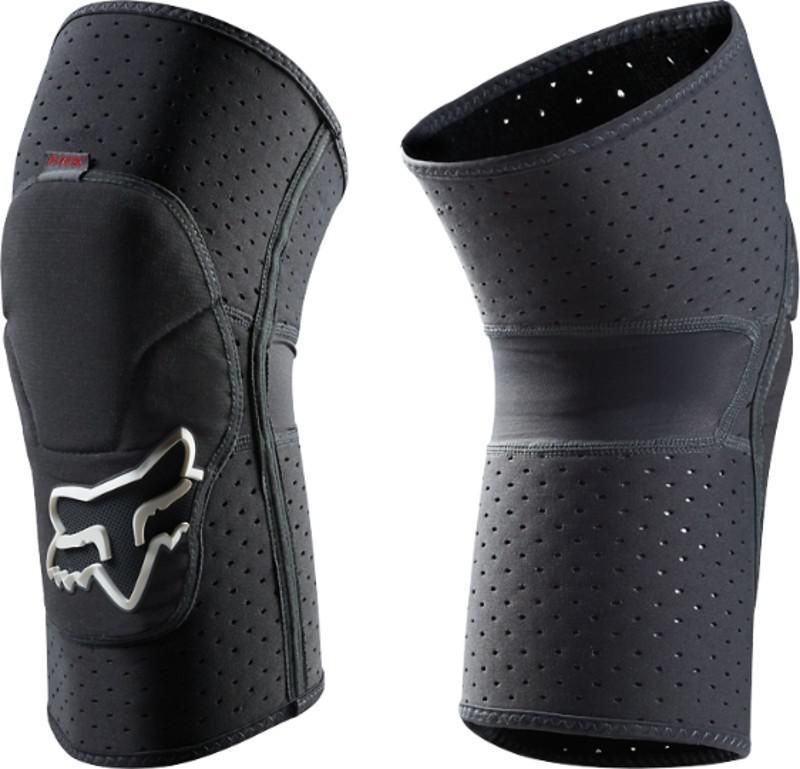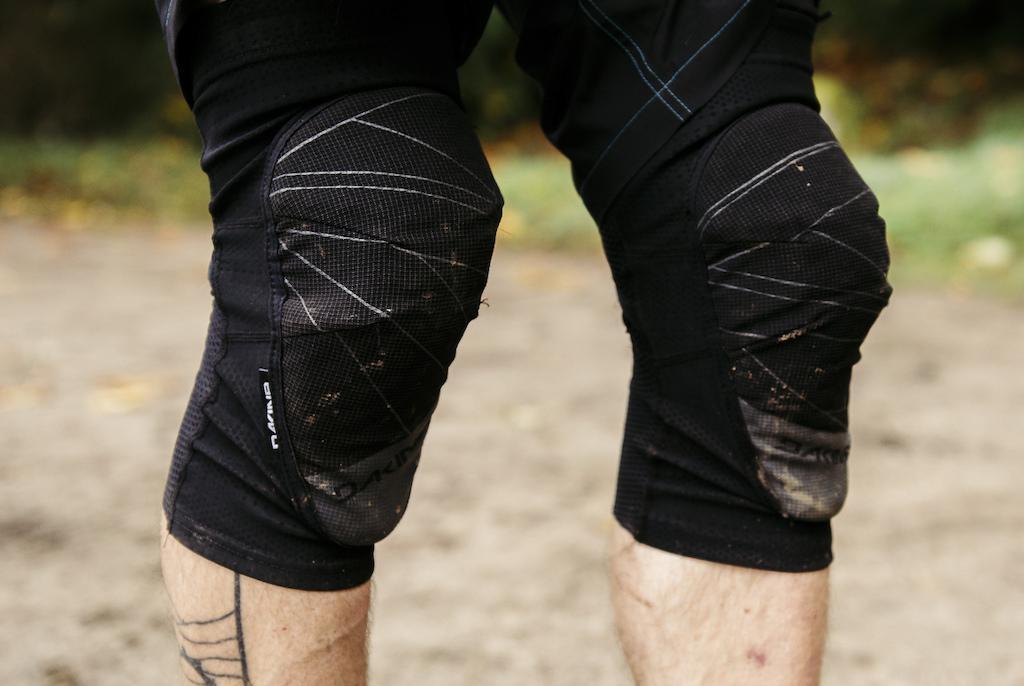The first image is the image on the left, the second image is the image on the right. For the images displayed, is the sentence "There are two pairs of legs." factually correct? Answer yes or no. No. The first image is the image on the left, the second image is the image on the right. Assess this claim about the two images: "There are exactly four legs visible.". Correct or not? Answer yes or no. No. 